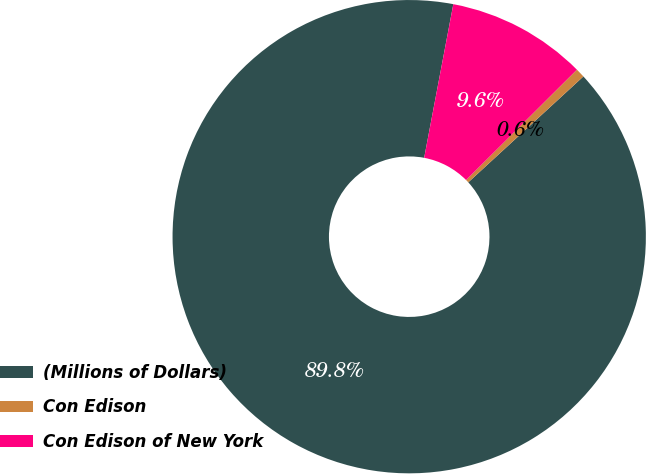Convert chart to OTSL. <chart><loc_0><loc_0><loc_500><loc_500><pie_chart><fcel>(Millions of Dollars)<fcel>Con Edison<fcel>Con Edison of New York<nl><fcel>89.82%<fcel>0.63%<fcel>9.55%<nl></chart> 